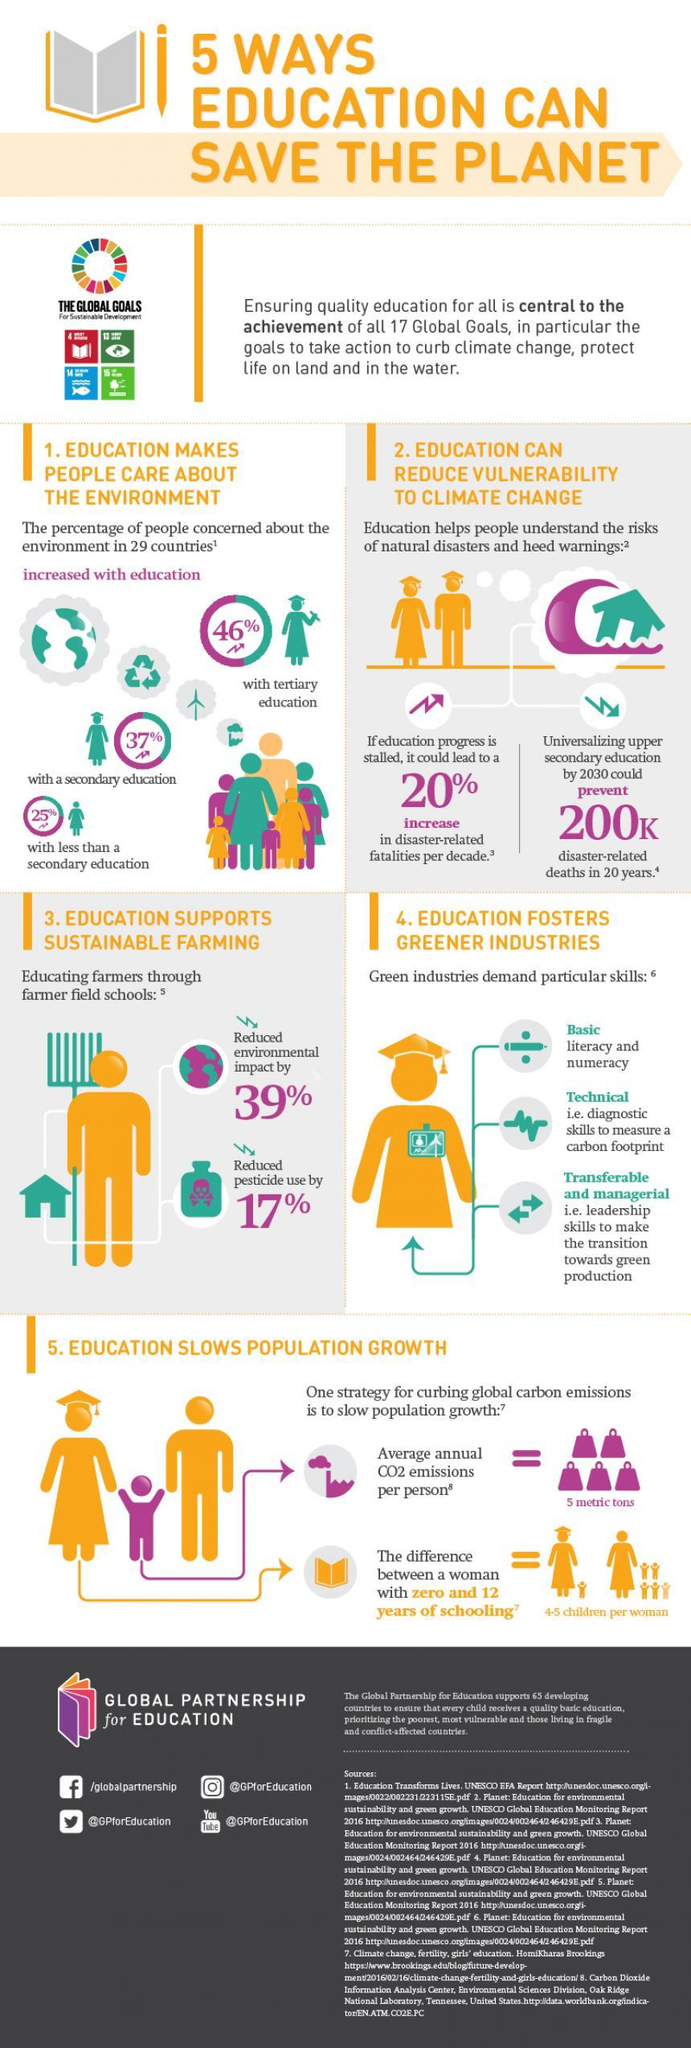Identify some key points in this picture. The tertiary education group is more concerned about the environment than those with secondary or less than secondary education. The average person emits 5 metric tons of CO2 per year, which is a significant contribution to climate change. The channel name mentioned is "@GPforEducation". The Instagram profile is @GPforEducation. The infographic displays 26 icons of people, including children. 